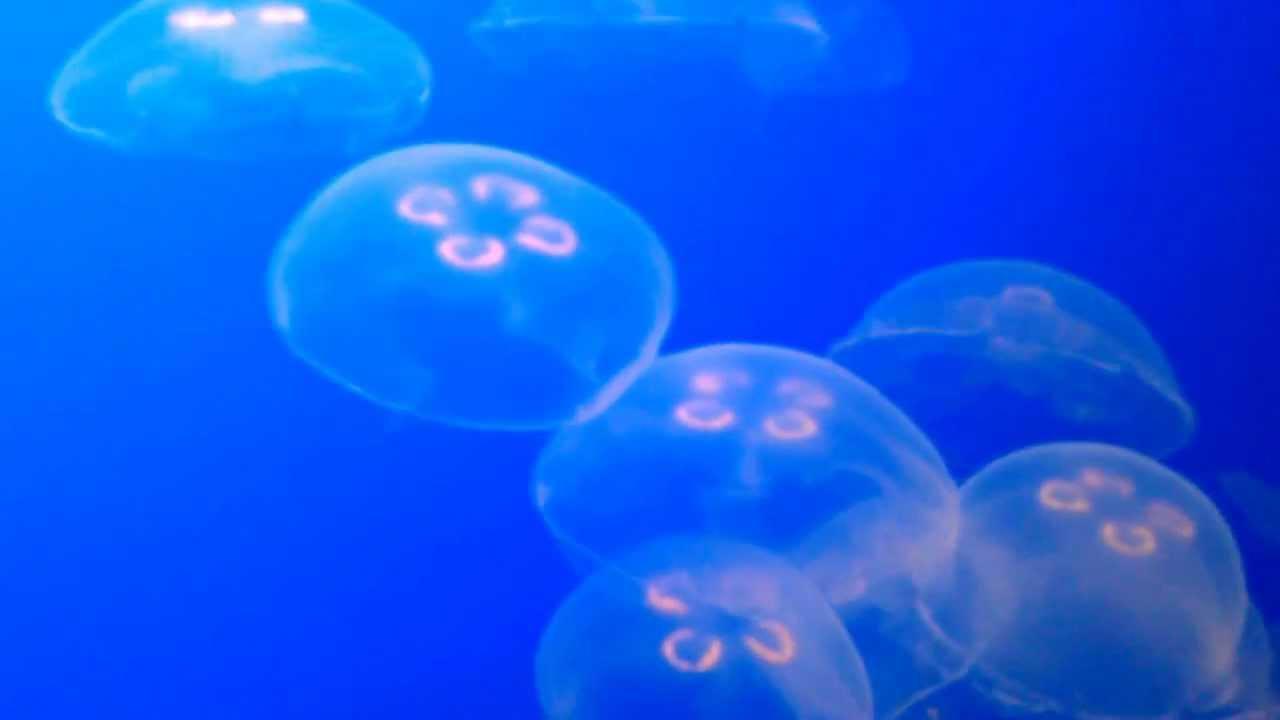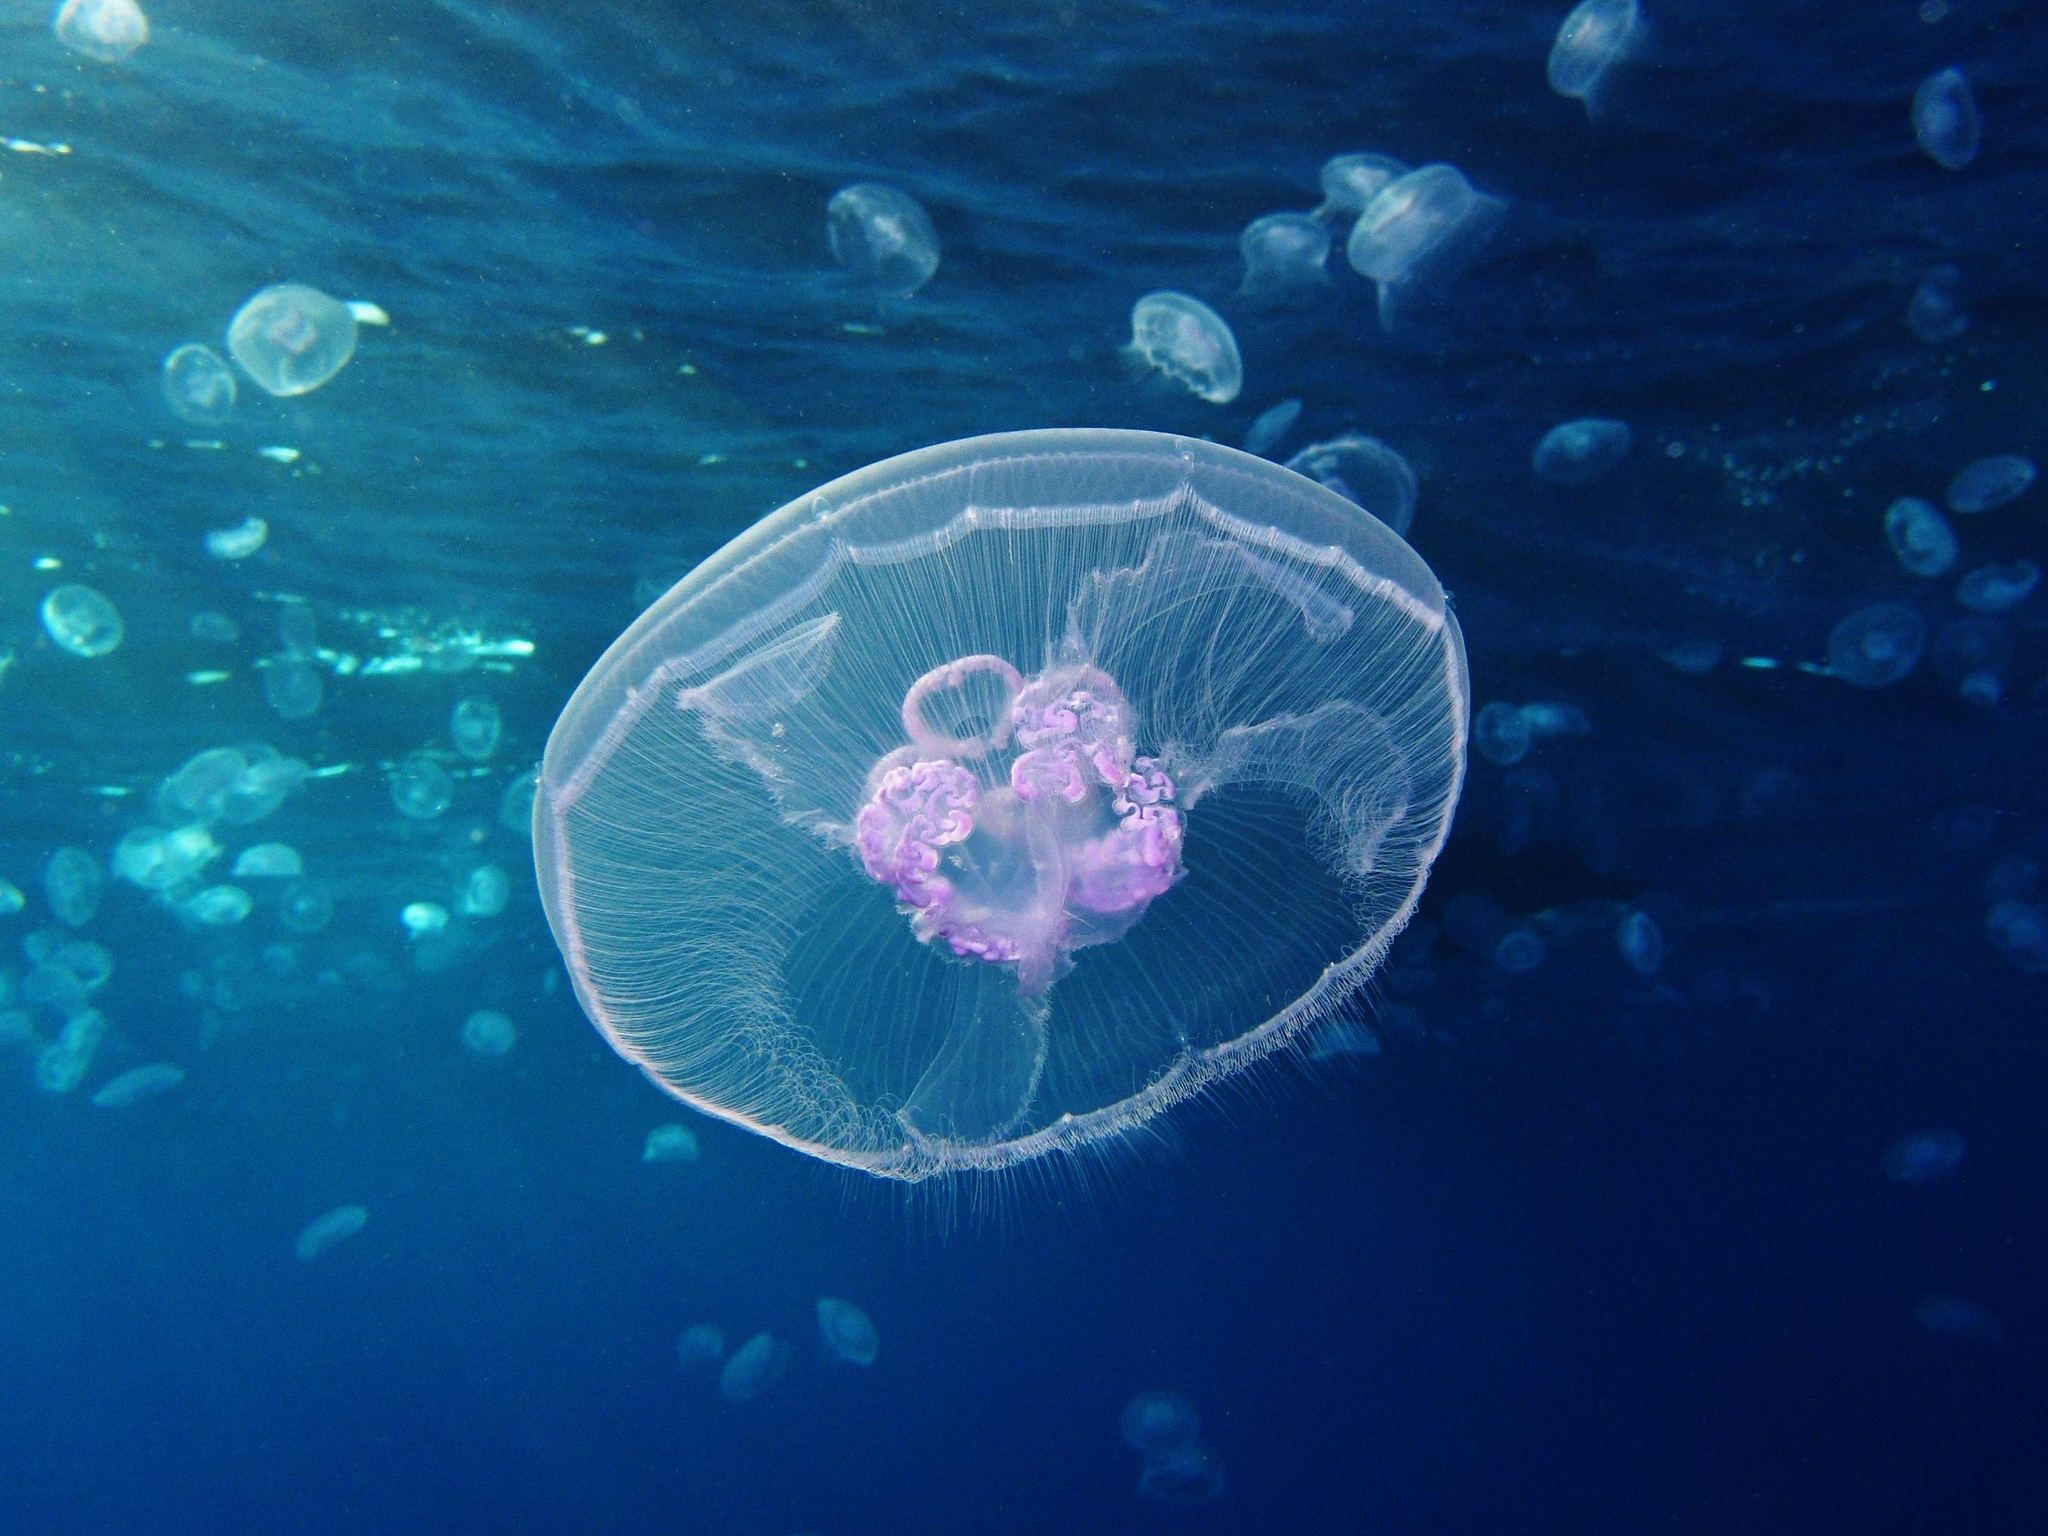The first image is the image on the left, the second image is the image on the right. Evaluate the accuracy of this statement regarding the images: "Each image includes one jellyfish viewed with its """"cap"""" head-on, showing something that resembles a neon-lit four-leaf clover.". Is it true? Answer yes or no. No. 